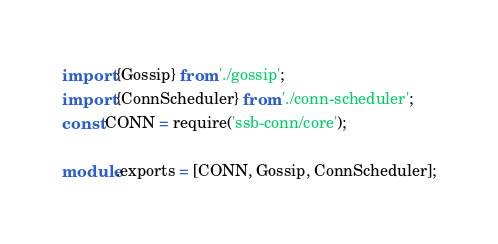<code> <loc_0><loc_0><loc_500><loc_500><_TypeScript_>import {Gossip} from './gossip';
import {ConnScheduler} from './conn-scheduler';
const CONN = require('ssb-conn/core');

module.exports = [CONN, Gossip, ConnScheduler];
</code> 